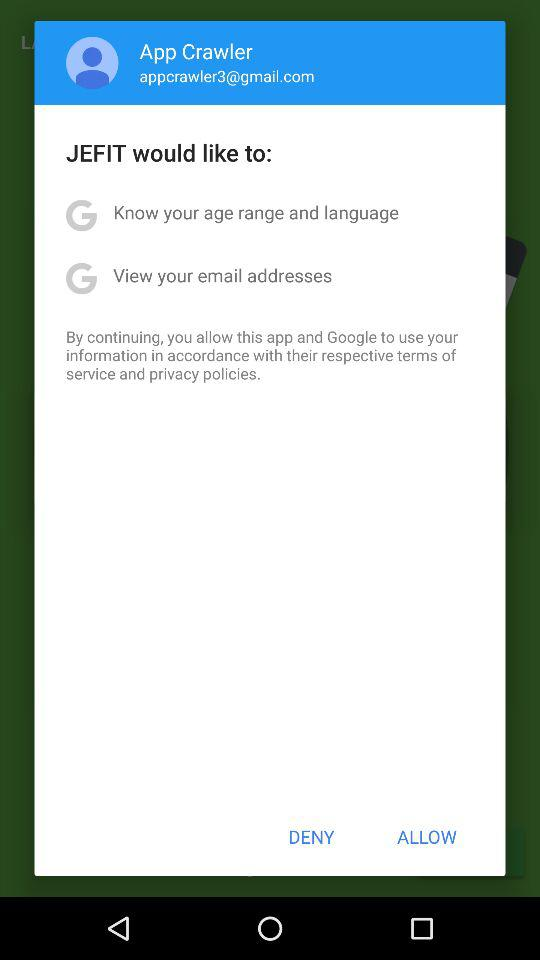What is the long form of JEFIT?
When the provided information is insufficient, respond with <no answer>. <no answer> 